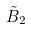Convert formula to latex. <formula><loc_0><loc_0><loc_500><loc_500>\tilde { B } _ { 2 }</formula> 